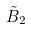Convert formula to latex. <formula><loc_0><loc_0><loc_500><loc_500>\tilde { B } _ { 2 }</formula> 